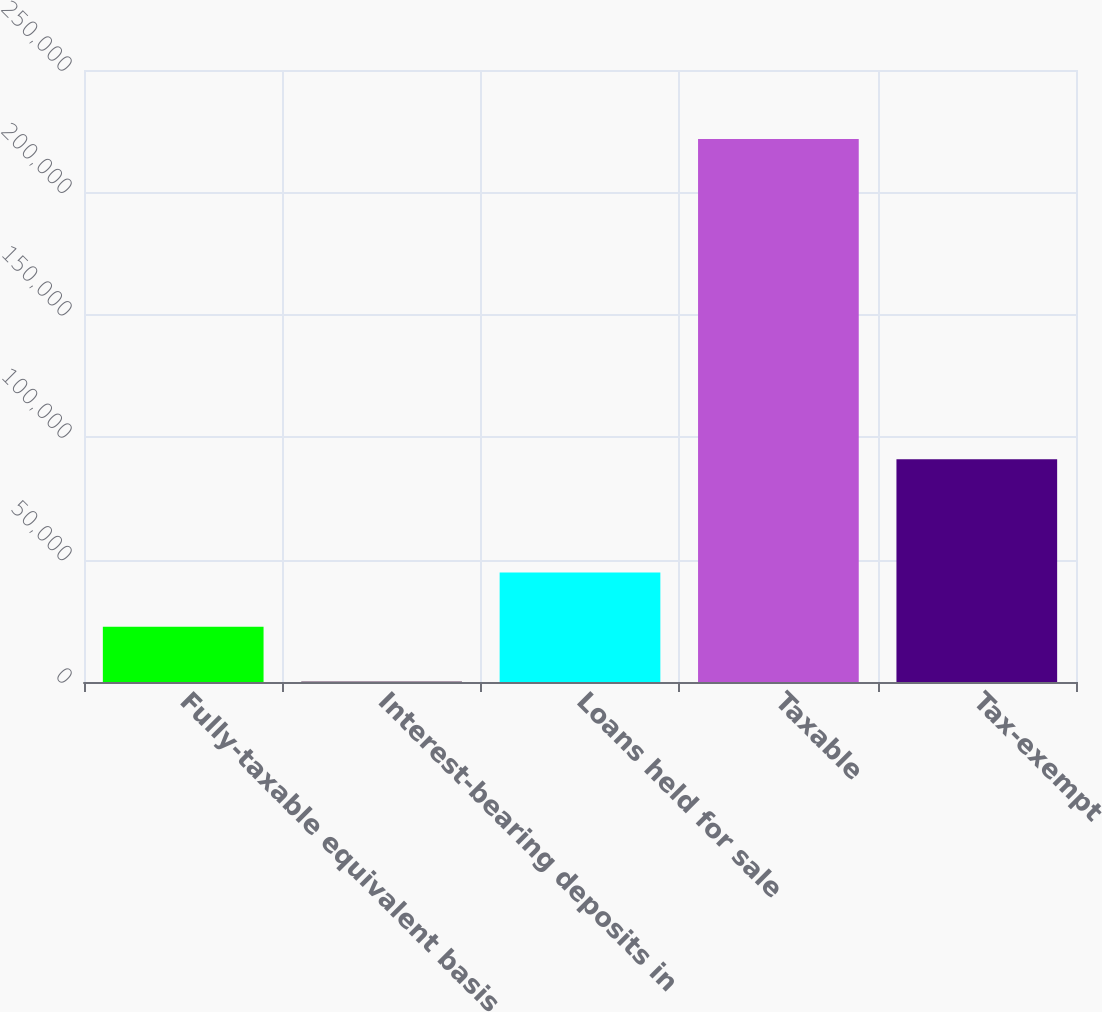Convert chart. <chart><loc_0><loc_0><loc_500><loc_500><bar_chart><fcel>Fully-taxable equivalent basis<fcel>Interest-bearing deposits in<fcel>Loans held for sale<fcel>Taxable<fcel>Tax-exempt<nl><fcel>22576.9<fcel>443<fcel>44710.8<fcel>221782<fcel>90972<nl></chart> 